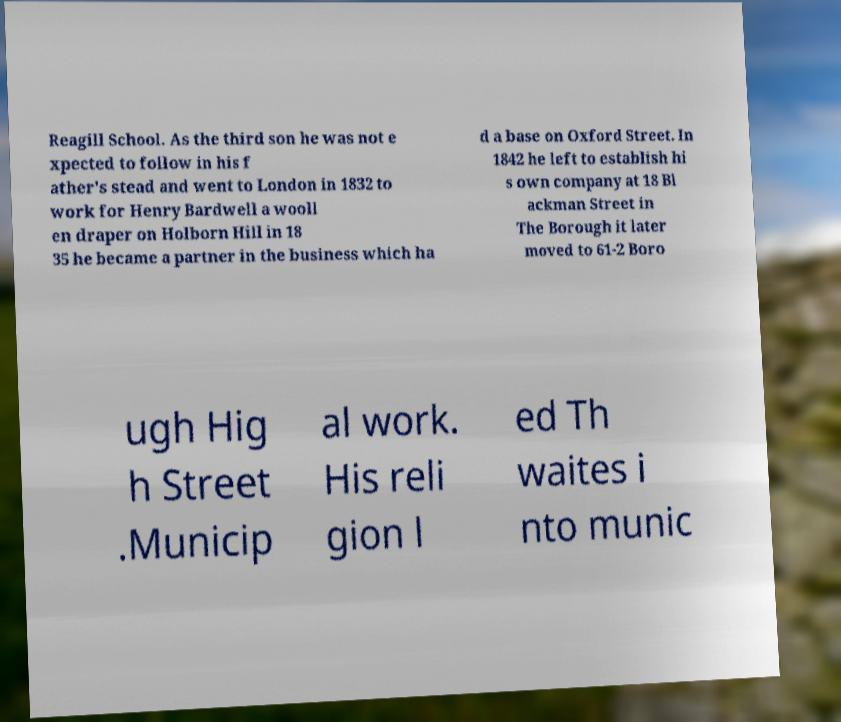Could you assist in decoding the text presented in this image and type it out clearly? Reagill School. As the third son he was not e xpected to follow in his f ather's stead and went to London in 1832 to work for Henry Bardwell a wooll en draper on Holborn Hill in 18 35 he became a partner in the business which ha d a base on Oxford Street. In 1842 he left to establish hi s own company at 18 Bl ackman Street in The Borough it later moved to 61-2 Boro ugh Hig h Street .Municip al work. His reli gion l ed Th waites i nto munic 